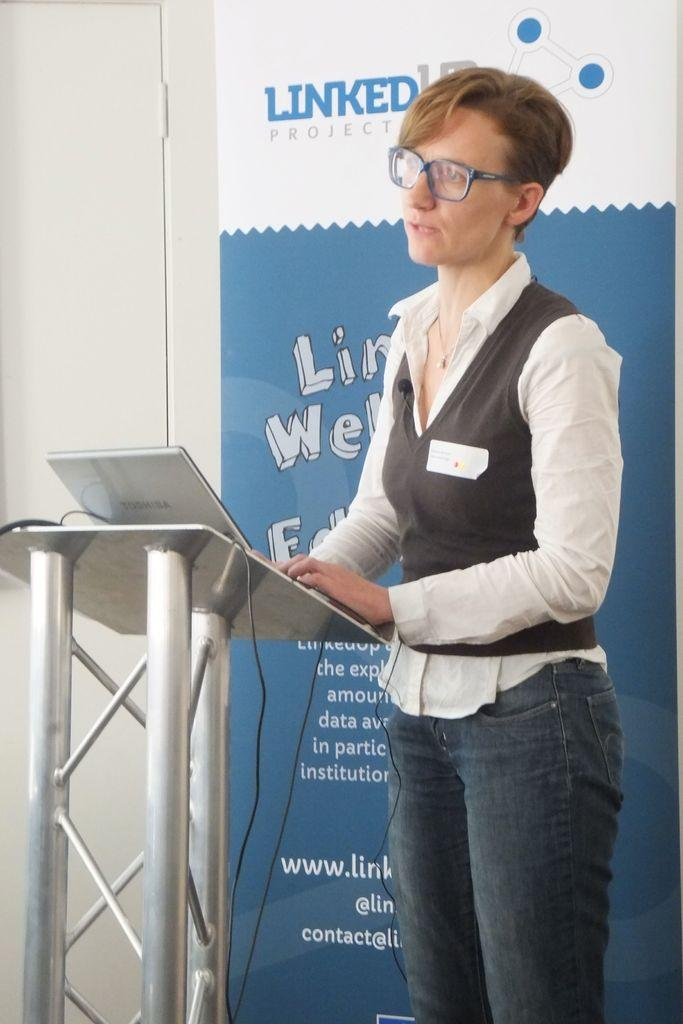What is the woman doing in the image? The woman is standing near a podium in the image. What object is on the podium? There is a laptop on the podium. What else can be seen in the image besides the woman and the laptop? There is a banner visible in the image. How many books are on the podium with the laptop? There are no books visible on the podium in the image. Is there a snail crawling on the banner in the image? There is no snail present in the image. 